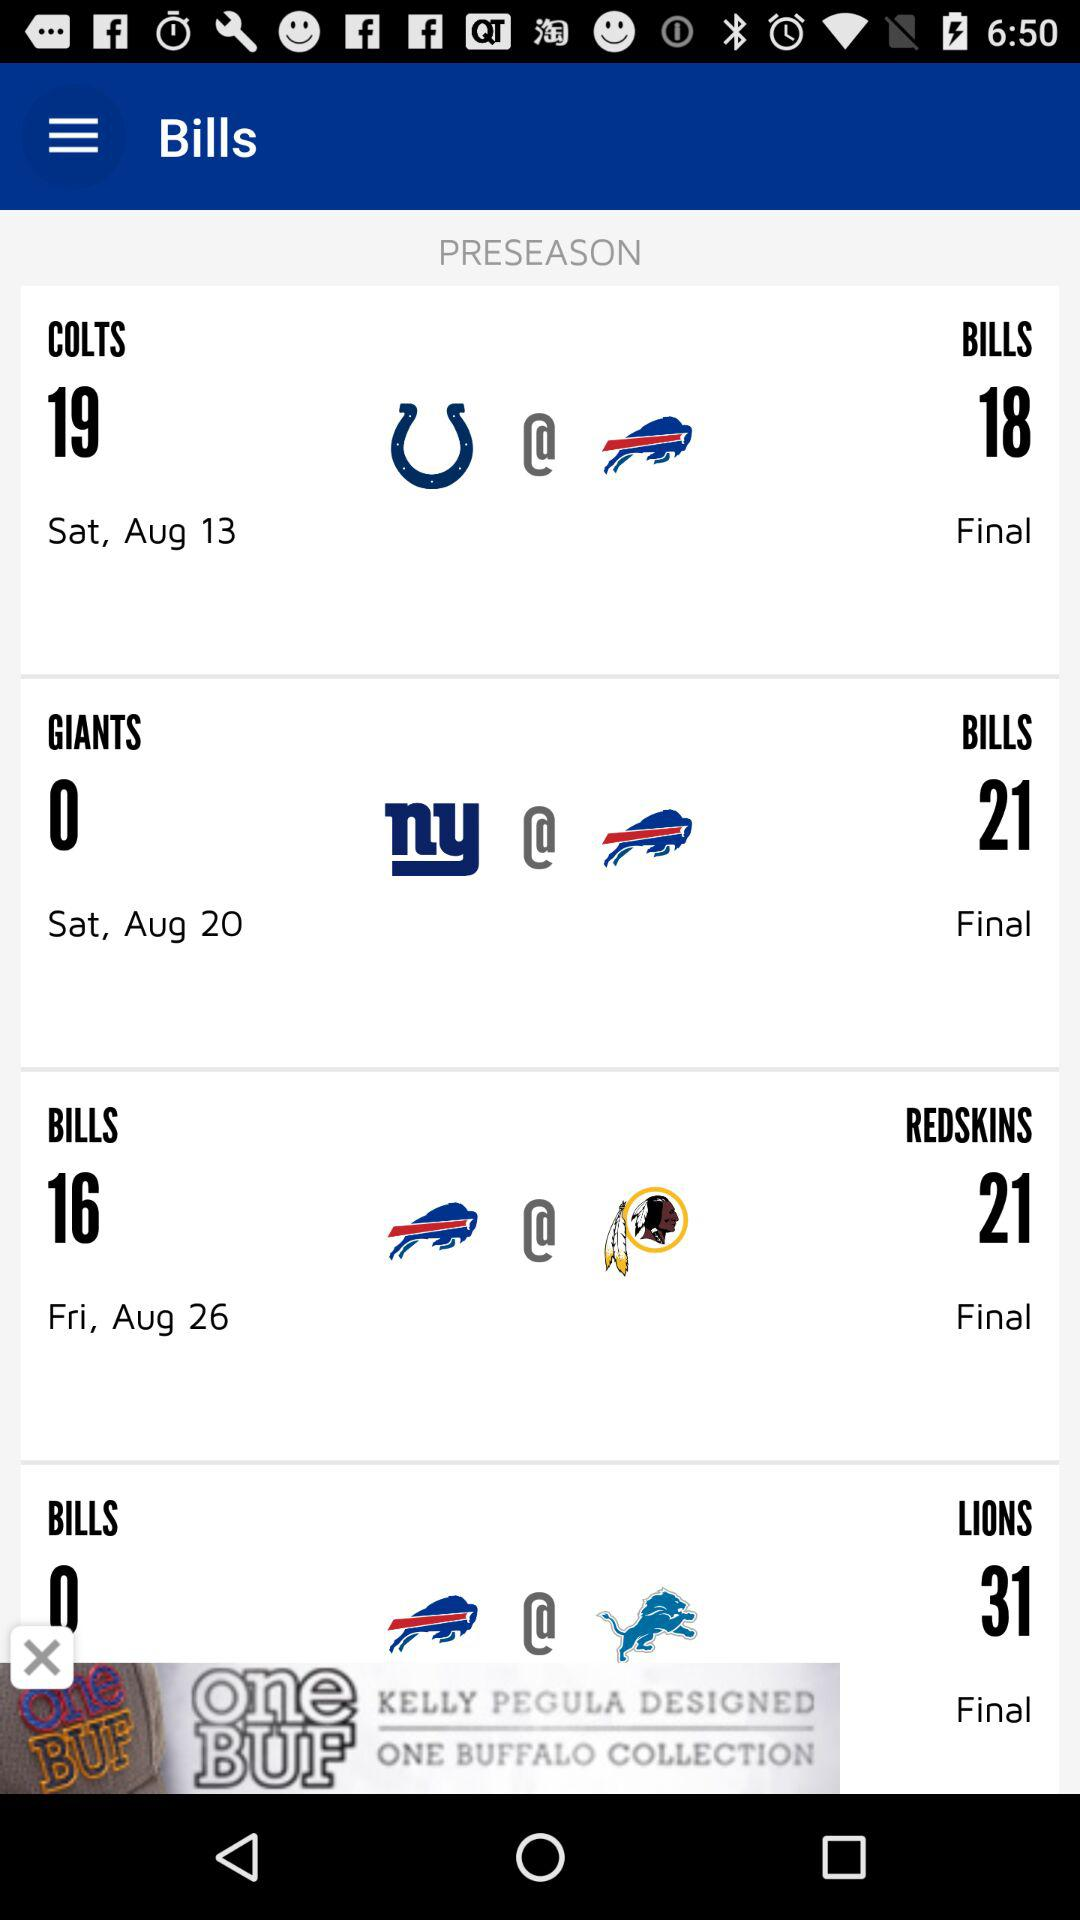What is the date of the final match between "COLTS" and "BILLS"? The date is Saturday, August 13. 